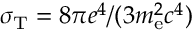<formula> <loc_0><loc_0><loc_500><loc_500>\sigma _ { T } = 8 \pi e ^ { 4 } / ( 3 m _ { e } ^ { 2 } c ^ { 4 } )</formula> 